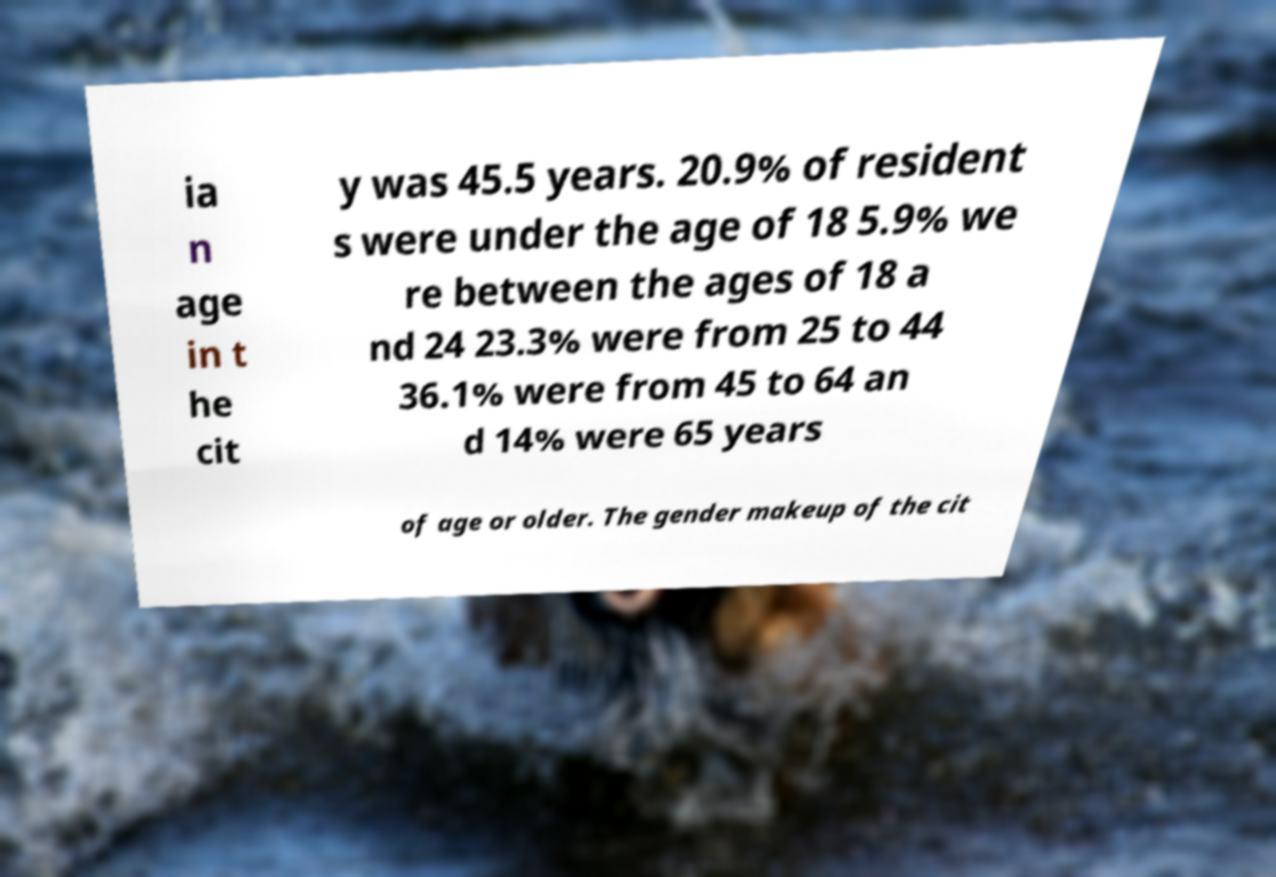Could you extract and type out the text from this image? ia n age in t he cit y was 45.5 years. 20.9% of resident s were under the age of 18 5.9% we re between the ages of 18 a nd 24 23.3% were from 25 to 44 36.1% were from 45 to 64 an d 14% were 65 years of age or older. The gender makeup of the cit 